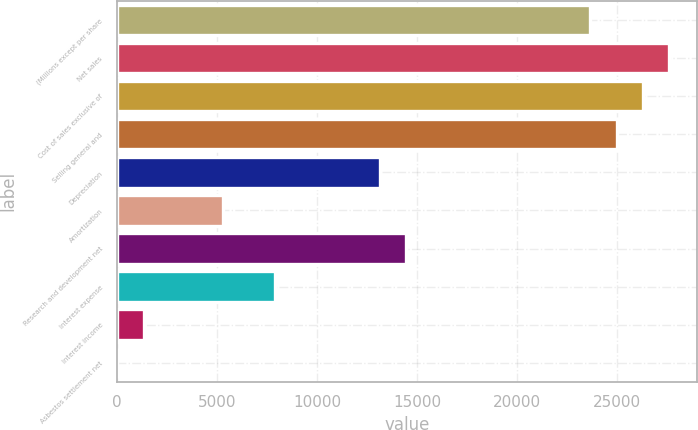<chart> <loc_0><loc_0><loc_500><loc_500><bar_chart><fcel>(Millions except per share<fcel>Net sales<fcel>Cost of sales exclusive of<fcel>Selling general and<fcel>Depreciation<fcel>Amortization<fcel>Research and development net<fcel>Interest expense<fcel>Interest income<fcel>Asbestos settlement net<nl><fcel>23665.8<fcel>27608.1<fcel>26294<fcel>24979.9<fcel>13153<fcel>5268.4<fcel>14467.1<fcel>7896.6<fcel>1326.1<fcel>12<nl></chart> 